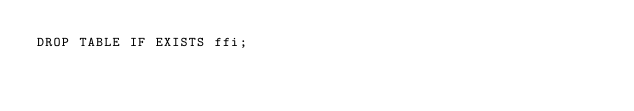Convert code to text. <code><loc_0><loc_0><loc_500><loc_500><_SQL_>DROP TABLE IF EXISTS ffi;
</code> 